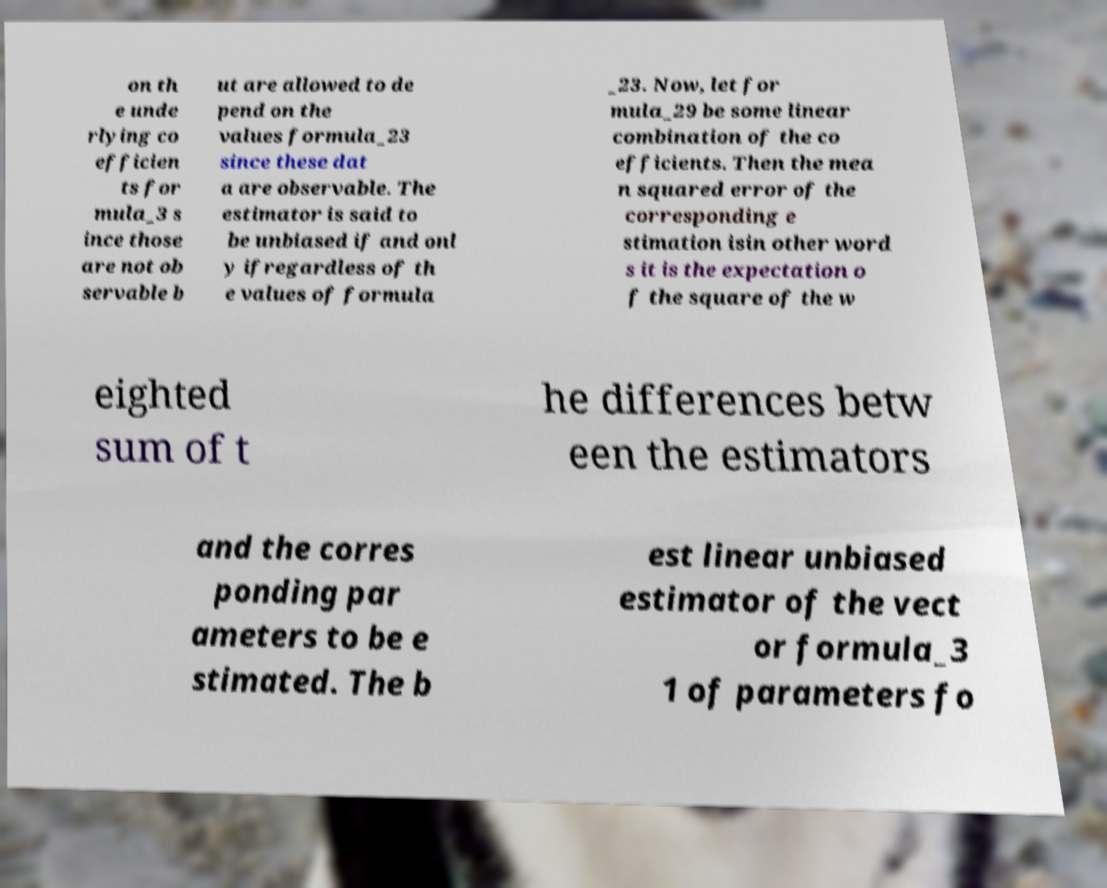What messages or text are displayed in this image? I need them in a readable, typed format. on th e unde rlying co efficien ts for mula_3 s ince those are not ob servable b ut are allowed to de pend on the values formula_23 since these dat a are observable. The estimator is said to be unbiased if and onl y ifregardless of th e values of formula _23. Now, let for mula_29 be some linear combination of the co efficients. Then the mea n squared error of the corresponding e stimation isin other word s it is the expectation o f the square of the w eighted sum of t he differences betw een the estimators and the corres ponding par ameters to be e stimated. The b est linear unbiased estimator of the vect or formula_3 1 of parameters fo 